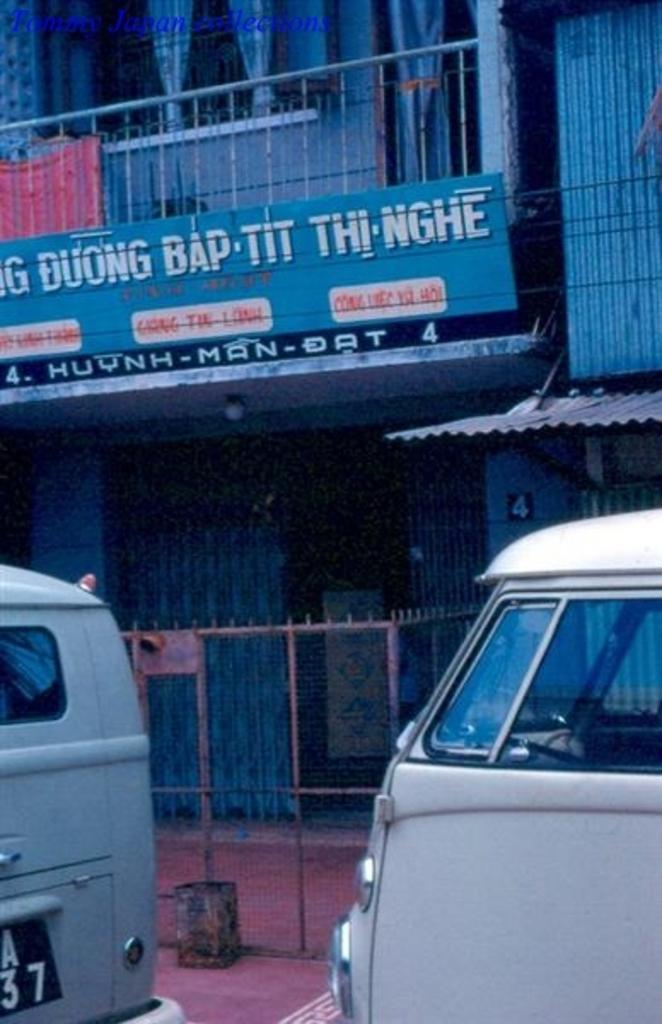How would you summarize this image in a sentence or two? In this image I can see two vehicles. In the background I can see the net fence and the building with railing, board and the curtains. 